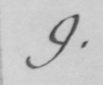What does this handwritten line say? 9 . 